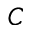<formula> <loc_0><loc_0><loc_500><loc_500>C</formula> 